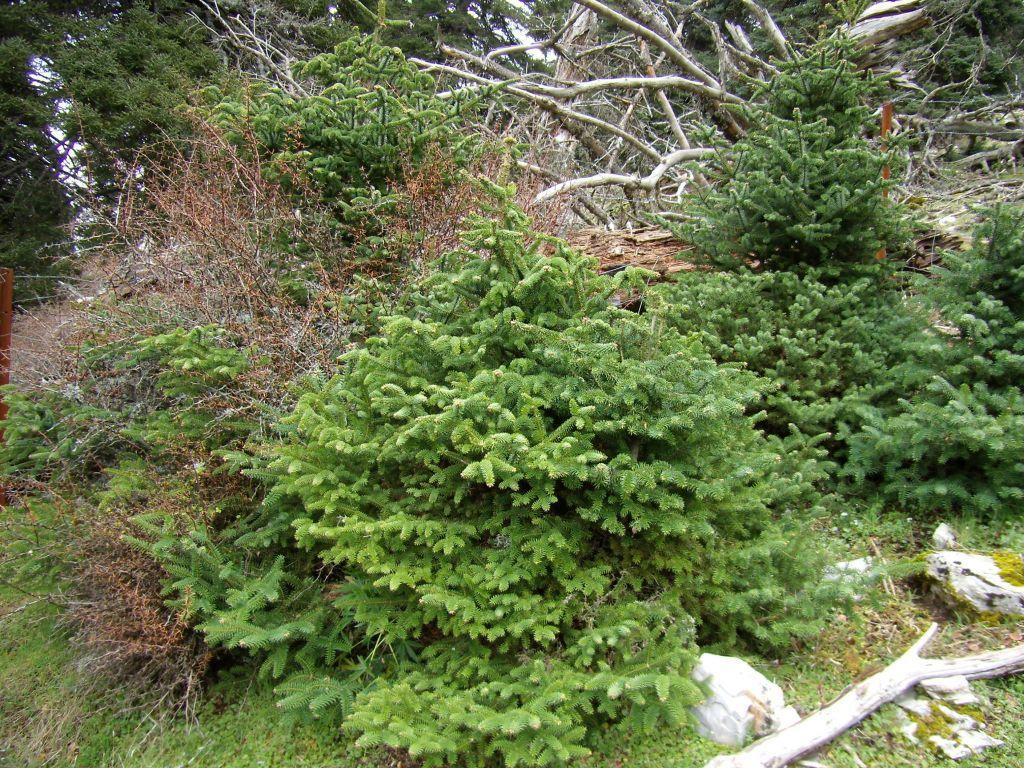What type of vegetation can be seen in the image? There are many trees, plants, and grass in the image. Where are the woods and stones located in the image? They are in the bottom right corner of the image. What type of noise can be heard coming from the plane in the image? There is no plane present in the image, so no noise can be heard from a plane. 